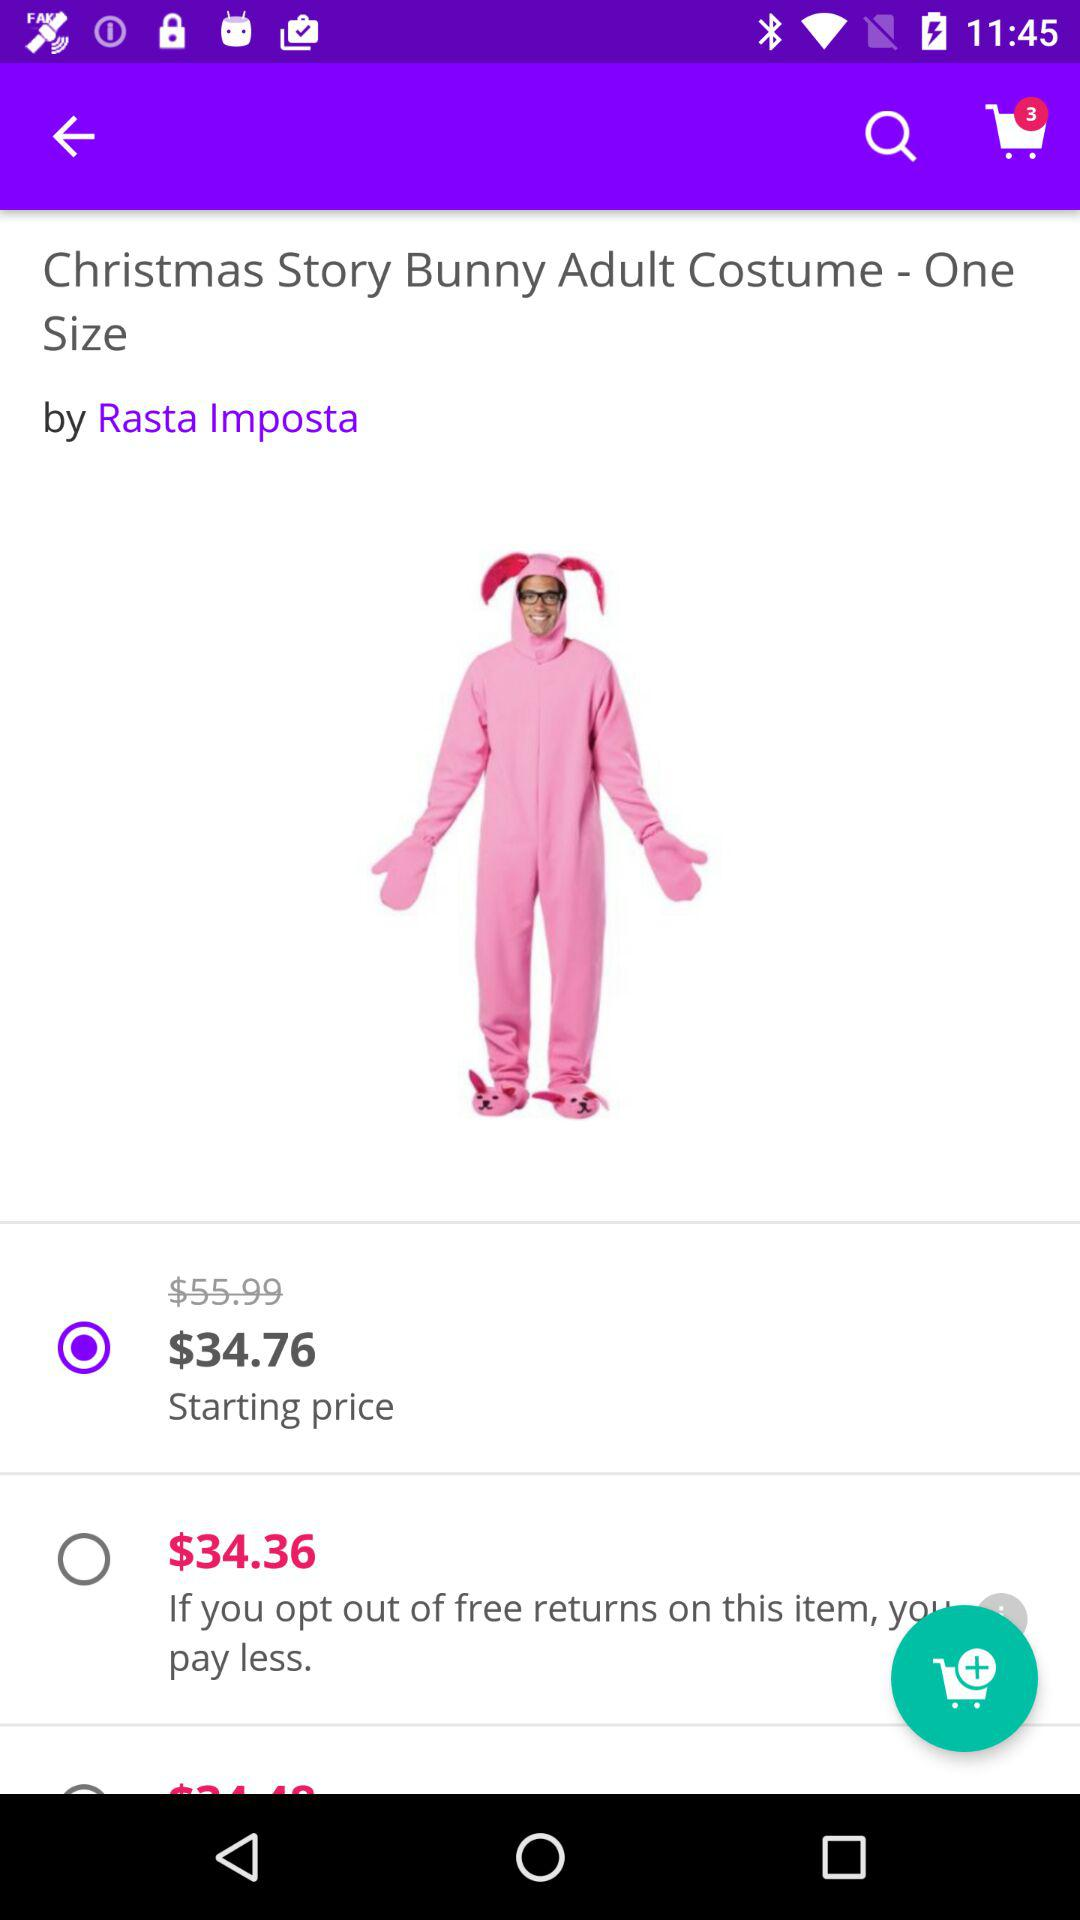What is the name of the product? The name of the product is "Christmas Story Bunny Adult Costume". 